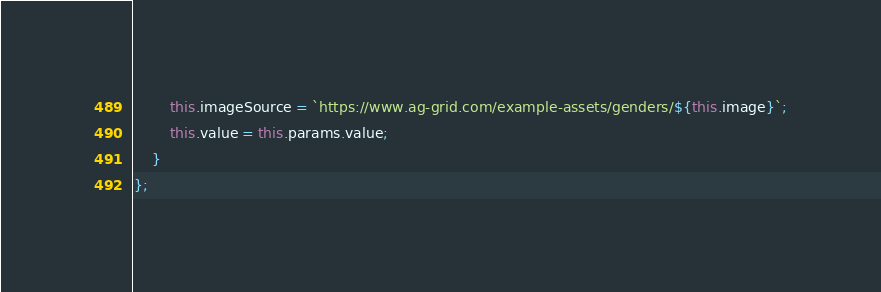<code> <loc_0><loc_0><loc_500><loc_500><_JavaScript_>        this.imageSource = `https://www.ag-grid.com/example-assets/genders/${this.image}`;
        this.value = this.params.value;
    }
};
</code> 